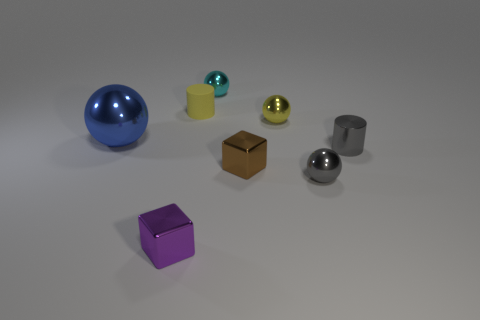How many objects are either yellow rubber cubes or small matte cylinders?
Offer a terse response. 1. What size is the shiny sphere that is to the right of the tiny cyan metal sphere and in front of the small yellow sphere?
Offer a terse response. Small. What number of other cyan things have the same material as the small cyan thing?
Your response must be concise. 0. There is a cylinder that is made of the same material as the large blue object; what color is it?
Keep it short and to the point. Gray. There is a ball that is in front of the large blue ball; is it the same color as the matte object?
Offer a terse response. No. There is a cube left of the cyan ball; what is its material?
Give a very brief answer. Metal. Are there an equal number of shiny blocks behind the large blue thing and brown shiny blocks?
Your answer should be very brief. No. How many metallic balls have the same color as the rubber object?
Ensure brevity in your answer.  1. What color is the other large metal object that is the same shape as the cyan thing?
Keep it short and to the point. Blue. Is the size of the yellow shiny object the same as the purple thing?
Your answer should be compact. Yes. 